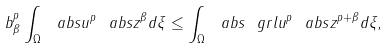<formula> <loc_0><loc_0><loc_500><loc_500>b _ { \beta } ^ { p } \int _ { \Omega } { \ a b s { u } ^ { p } } { \ a b s z ^ { \beta } } d \xi \leq \int _ { \Omega } \ a b s { \ g r l u } ^ { p } \ a b s z ^ { p + \beta } d \xi ,</formula> 